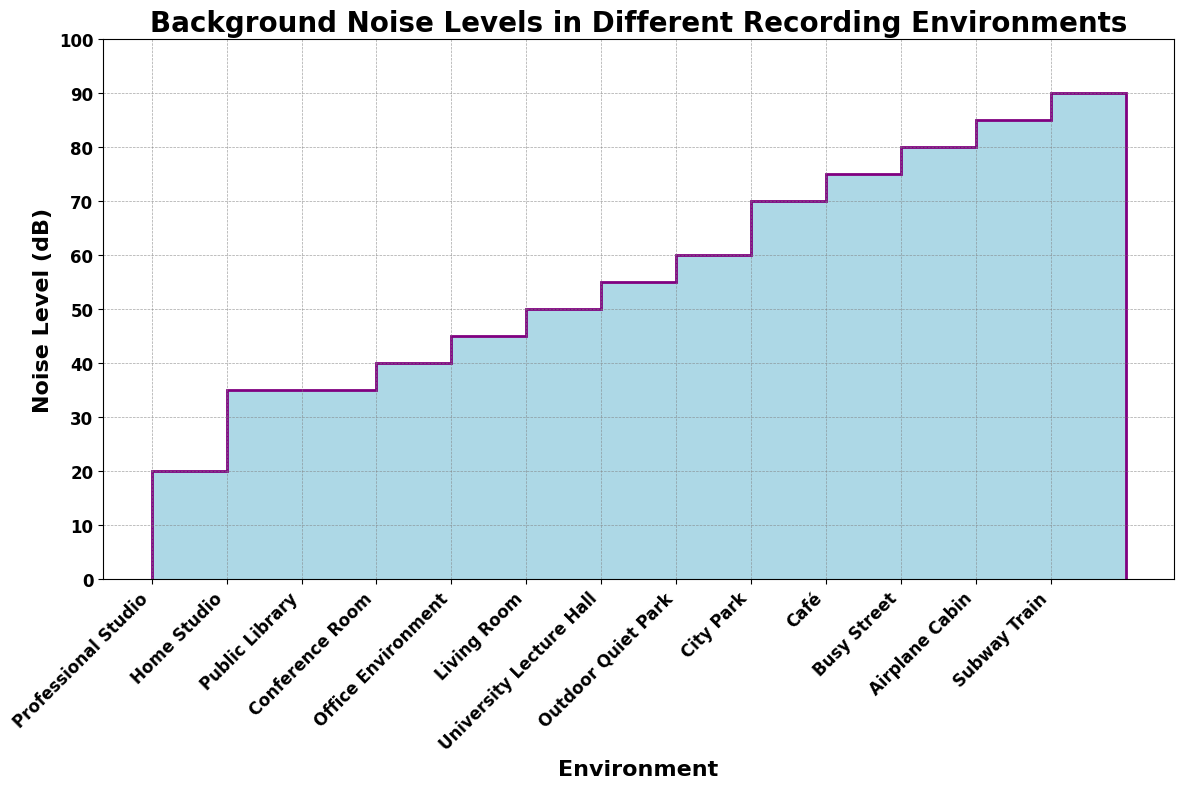What's the environment with the lowest noise level? The stairs plot shows the noise levels for different environments, and the lowest point on the vertical axis corresponds to the Professional Studio.
Answer: Professional Studio Which environment has the highest background noise level? The stairs plot indicates that the highest point on the vertical axis represents the environment with the highest noise level, which is the Subway Train.
Answer: Subway Train What is the difference in noise levels between a Professional Studio and an Airplane Cabin? From the plot, the Professional Studio is at 20 dB, and the Airplane Cabin is at 85 dB, so 85 - 20 = 65 dB.
Answer: 65 dB Which two environments have a noise level of 35 dB? The stairs plot shows two peaks at the 35 dB mark, which correspond to Home Studio and Public Library.
Answer: Home Studio and Public Library What is the median noise level of all recorded environments? Sorting the noise levels in ascending order: 20, 35, 35, 40, 45, 50, 55, 60, 70, 75, 80, 85, 90. The median is the middle value of this sorted list, which is 55 dB from the University Lecture Hall.
Answer: 55 dB Which environment has a noise level closest to 50 dB? By looking at the stairs plot, the environment that corresponds to the 50 dB mark is the Living Room.
Answer: Living Room Compare the noise levels of Office Environment and Café. Which is noisier? The Office Environment has a noise level of 45 dB while the Café has 75 dB. Therefore, the Café is noisier.
Answer: Café What is the combined noise level of the Home Studio, Office Environment, and Public Library? Adding their noise levels: 35 (Home Studio) + 45 (Office Environment) + 35 (Public Library) = 115 dB.
Answer: 115 dB How many environments have noise levels greater than 60 dB? Environments with noise levels above 60 dB from the plot are City Park (70 dB), Busy Street (80 dB), Café (75 dB), Subway Train (90 dB), and Airplane Cabin (85 dB). There are 5 such environments.
Answer: 5 Which environment's noise level is exactly midway between the Living Room and City Park levels? Living Room is at 50 dB, and City Park is at 70 dB, so the midway point is (50 + 70) / 2 = 60 dB, which corresponds to the Outdoor Quiet Park.
Answer: Outdoor Quiet Park 